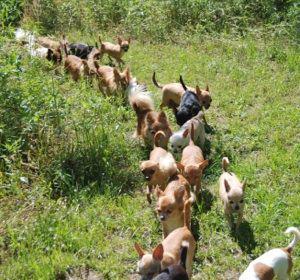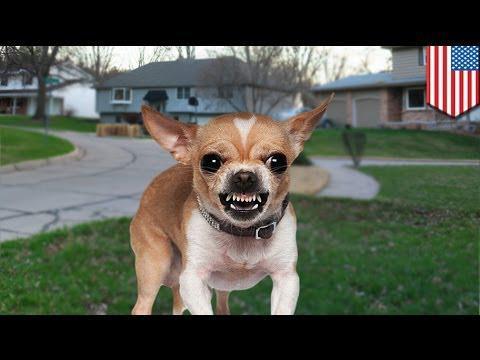The first image is the image on the left, the second image is the image on the right. Given the left and right images, does the statement "There is exactly one animal in one of the images." hold true? Answer yes or no. Yes. 